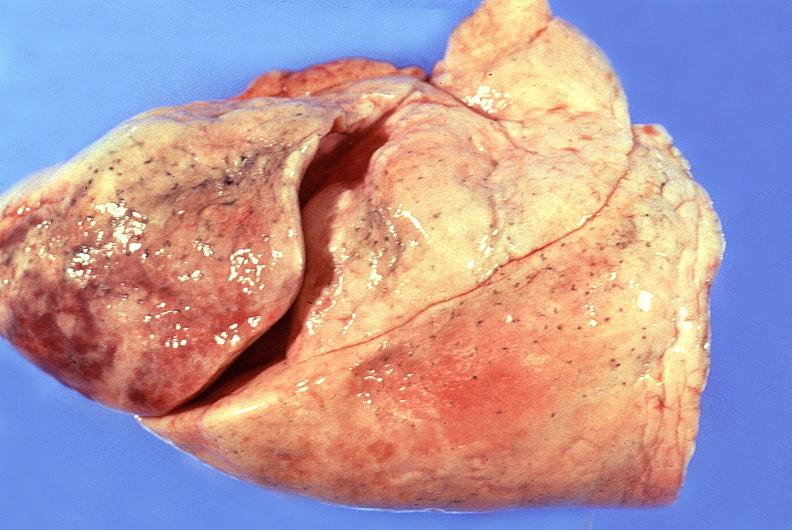s respiratory present?
Answer the question using a single word or phrase. Yes 